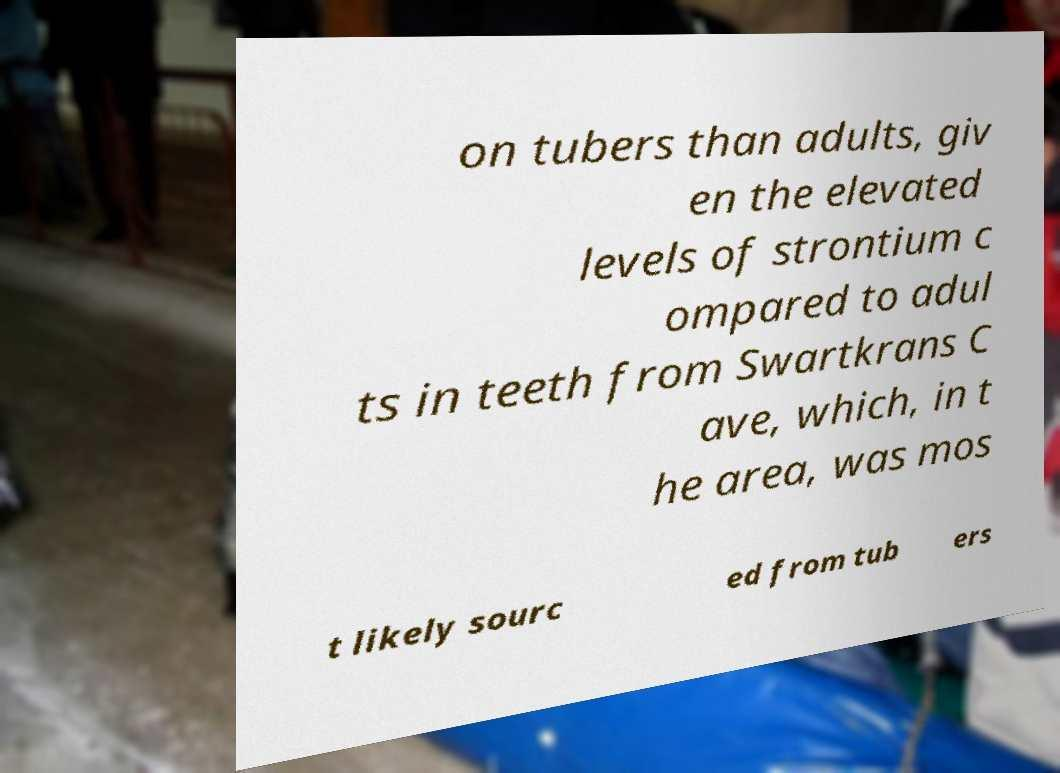Can you accurately transcribe the text from the provided image for me? on tubers than adults, giv en the elevated levels of strontium c ompared to adul ts in teeth from Swartkrans C ave, which, in t he area, was mos t likely sourc ed from tub ers 